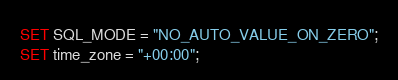<code> <loc_0><loc_0><loc_500><loc_500><_SQL_>
SET SQL_MODE = "NO_AUTO_VALUE_ON_ZERO";
SET time_zone = "+00:00";

</code> 